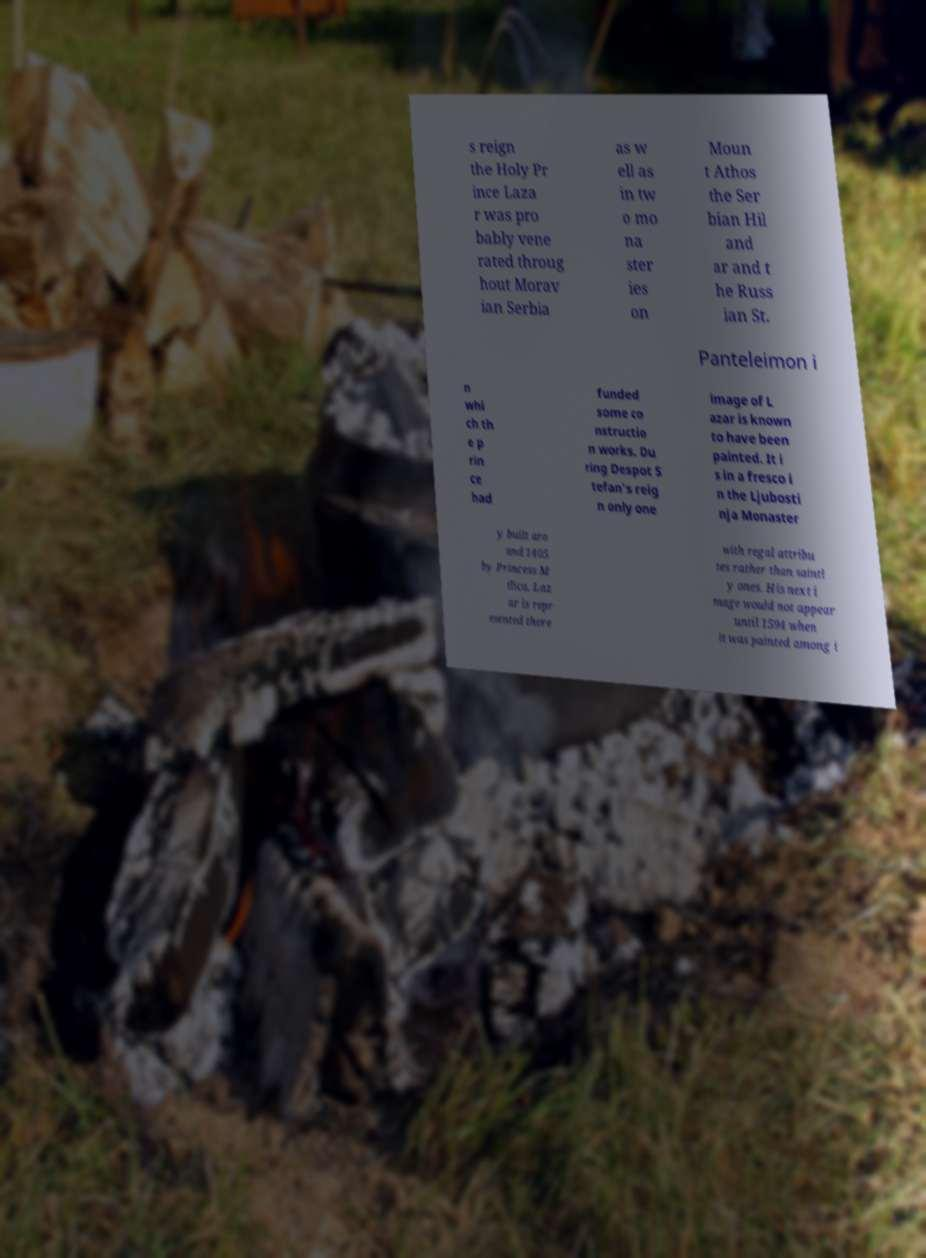Could you extract and type out the text from this image? s reign the Holy Pr ince Laza r was pro bably vene rated throug hout Morav ian Serbia as w ell as in tw o mo na ster ies on Moun t Athos the Ser bian Hil and ar and t he Russ ian St. Panteleimon i n whi ch th e p rin ce had funded some co nstructio n works. Du ring Despot S tefan's reig n only one image of L azar is known to have been painted. It i s in a fresco i n the Ljubosti nja Monaster y built aro und 1405 by Princess M ilica. Laz ar is repr esented there with regal attribu tes rather than saintl y ones. His next i mage would not appear until 1594 when it was painted among i 